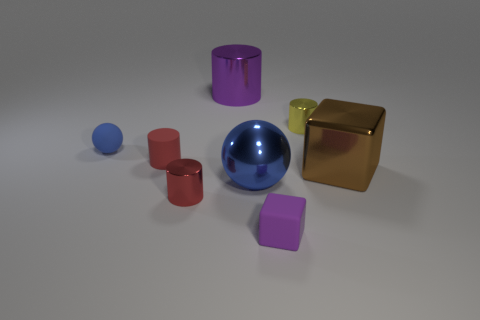Add 1 red metal cylinders. How many objects exist? 9 Subtract all spheres. How many objects are left? 6 Subtract 0 blue blocks. How many objects are left? 8 Subtract all purple matte cubes. Subtract all brown things. How many objects are left? 6 Add 8 tiny purple blocks. How many tiny purple blocks are left? 9 Add 2 rubber spheres. How many rubber spheres exist? 3 